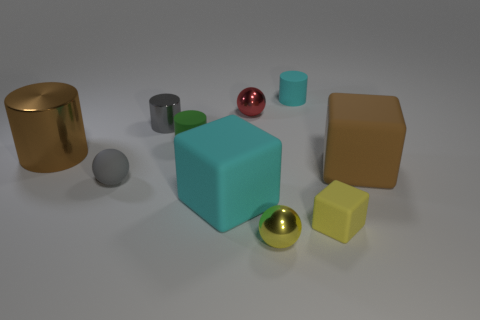Subtract all balls. How many objects are left? 7 Add 5 green cylinders. How many green cylinders exist? 6 Subtract 0 blue balls. How many objects are left? 10 Subtract all yellow matte blocks. Subtract all large brown rubber things. How many objects are left? 8 Add 8 tiny yellow shiny things. How many tiny yellow shiny things are left? 9 